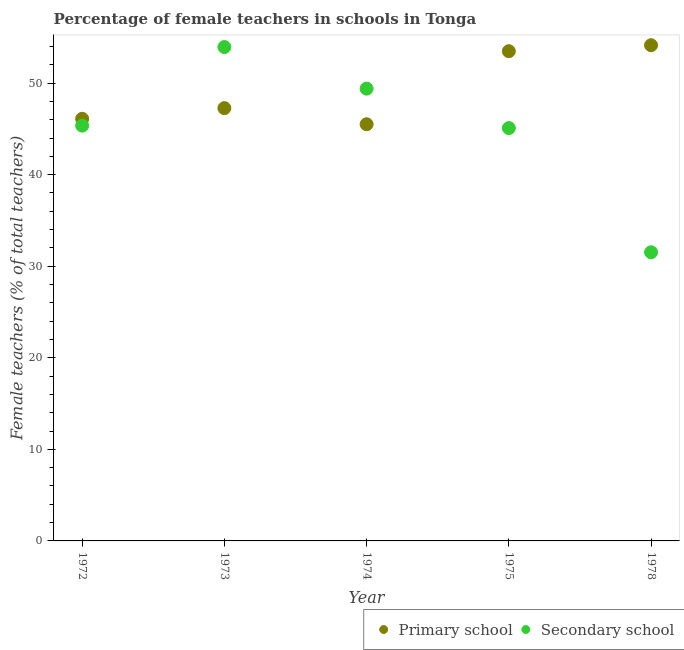How many different coloured dotlines are there?
Ensure brevity in your answer.  2. What is the percentage of female teachers in secondary schools in 1978?
Give a very brief answer. 31.53. Across all years, what is the maximum percentage of female teachers in secondary schools?
Provide a short and direct response. 53.94. Across all years, what is the minimum percentage of female teachers in secondary schools?
Give a very brief answer. 31.53. In which year was the percentage of female teachers in primary schools maximum?
Offer a very short reply. 1978. In which year was the percentage of female teachers in primary schools minimum?
Ensure brevity in your answer.  1974. What is the total percentage of female teachers in primary schools in the graph?
Keep it short and to the point. 246.51. What is the difference between the percentage of female teachers in primary schools in 1972 and that in 1973?
Offer a terse response. -1.16. What is the difference between the percentage of female teachers in primary schools in 1972 and the percentage of female teachers in secondary schools in 1978?
Ensure brevity in your answer.  14.58. What is the average percentage of female teachers in secondary schools per year?
Offer a terse response. 45.06. In the year 1975, what is the difference between the percentage of female teachers in secondary schools and percentage of female teachers in primary schools?
Your answer should be very brief. -8.4. What is the ratio of the percentage of female teachers in primary schools in 1973 to that in 1975?
Your answer should be very brief. 0.88. What is the difference between the highest and the second highest percentage of female teachers in primary schools?
Offer a very short reply. 0.65. What is the difference between the highest and the lowest percentage of female teachers in secondary schools?
Provide a succinct answer. 22.42. Is the sum of the percentage of female teachers in primary schools in 1972 and 1974 greater than the maximum percentage of female teachers in secondary schools across all years?
Provide a succinct answer. Yes. Is the percentage of female teachers in primary schools strictly less than the percentage of female teachers in secondary schools over the years?
Provide a succinct answer. No. What is the difference between two consecutive major ticks on the Y-axis?
Give a very brief answer. 10. Are the values on the major ticks of Y-axis written in scientific E-notation?
Make the answer very short. No. Where does the legend appear in the graph?
Offer a very short reply. Bottom right. How many legend labels are there?
Provide a succinct answer. 2. How are the legend labels stacked?
Give a very brief answer. Horizontal. What is the title of the graph?
Provide a succinct answer. Percentage of female teachers in schools in Tonga. What is the label or title of the Y-axis?
Keep it short and to the point. Female teachers (% of total teachers). What is the Female teachers (% of total teachers) in Primary school in 1972?
Keep it short and to the point. 46.11. What is the Female teachers (% of total teachers) of Secondary school in 1972?
Provide a succinct answer. 45.36. What is the Female teachers (% of total teachers) in Primary school in 1973?
Your response must be concise. 47.27. What is the Female teachers (% of total teachers) in Secondary school in 1973?
Ensure brevity in your answer.  53.94. What is the Female teachers (% of total teachers) of Primary school in 1974?
Ensure brevity in your answer.  45.51. What is the Female teachers (% of total teachers) in Secondary school in 1974?
Your answer should be compact. 49.4. What is the Female teachers (% of total teachers) of Primary school in 1975?
Provide a succinct answer. 53.49. What is the Female teachers (% of total teachers) in Secondary school in 1975?
Offer a very short reply. 45.09. What is the Female teachers (% of total teachers) in Primary school in 1978?
Your answer should be compact. 54.14. What is the Female teachers (% of total teachers) of Secondary school in 1978?
Give a very brief answer. 31.53. Across all years, what is the maximum Female teachers (% of total teachers) in Primary school?
Provide a succinct answer. 54.14. Across all years, what is the maximum Female teachers (% of total teachers) in Secondary school?
Offer a very short reply. 53.94. Across all years, what is the minimum Female teachers (% of total teachers) in Primary school?
Give a very brief answer. 45.51. Across all years, what is the minimum Female teachers (% of total teachers) of Secondary school?
Provide a short and direct response. 31.53. What is the total Female teachers (% of total teachers) of Primary school in the graph?
Your response must be concise. 246.51. What is the total Female teachers (% of total teachers) in Secondary school in the graph?
Offer a very short reply. 225.32. What is the difference between the Female teachers (% of total teachers) in Primary school in 1972 and that in 1973?
Your answer should be compact. -1.16. What is the difference between the Female teachers (% of total teachers) of Secondary school in 1972 and that in 1973?
Provide a short and direct response. -8.59. What is the difference between the Female teachers (% of total teachers) of Primary school in 1972 and that in 1974?
Offer a very short reply. 0.6. What is the difference between the Female teachers (% of total teachers) in Secondary school in 1972 and that in 1974?
Provide a short and direct response. -4.04. What is the difference between the Female teachers (% of total teachers) of Primary school in 1972 and that in 1975?
Your answer should be very brief. -7.38. What is the difference between the Female teachers (% of total teachers) of Secondary school in 1972 and that in 1975?
Offer a terse response. 0.27. What is the difference between the Female teachers (% of total teachers) in Primary school in 1972 and that in 1978?
Your answer should be very brief. -8.03. What is the difference between the Female teachers (% of total teachers) of Secondary school in 1972 and that in 1978?
Your answer should be compact. 13.83. What is the difference between the Female teachers (% of total teachers) in Primary school in 1973 and that in 1974?
Your answer should be very brief. 1.76. What is the difference between the Female teachers (% of total teachers) in Secondary school in 1973 and that in 1974?
Ensure brevity in your answer.  4.54. What is the difference between the Female teachers (% of total teachers) of Primary school in 1973 and that in 1975?
Offer a terse response. -6.22. What is the difference between the Female teachers (% of total teachers) in Secondary school in 1973 and that in 1975?
Provide a succinct answer. 8.85. What is the difference between the Female teachers (% of total teachers) of Primary school in 1973 and that in 1978?
Your answer should be compact. -6.87. What is the difference between the Female teachers (% of total teachers) in Secondary school in 1973 and that in 1978?
Your answer should be very brief. 22.42. What is the difference between the Female teachers (% of total teachers) of Primary school in 1974 and that in 1975?
Your answer should be very brief. -7.98. What is the difference between the Female teachers (% of total teachers) in Secondary school in 1974 and that in 1975?
Your response must be concise. 4.31. What is the difference between the Female teachers (% of total teachers) in Primary school in 1974 and that in 1978?
Provide a succinct answer. -8.63. What is the difference between the Female teachers (% of total teachers) in Secondary school in 1974 and that in 1978?
Provide a succinct answer. 17.87. What is the difference between the Female teachers (% of total teachers) in Primary school in 1975 and that in 1978?
Provide a succinct answer. -0.65. What is the difference between the Female teachers (% of total teachers) in Secondary school in 1975 and that in 1978?
Your response must be concise. 13.56. What is the difference between the Female teachers (% of total teachers) in Primary school in 1972 and the Female teachers (% of total teachers) in Secondary school in 1973?
Offer a very short reply. -7.84. What is the difference between the Female teachers (% of total teachers) of Primary school in 1972 and the Female teachers (% of total teachers) of Secondary school in 1974?
Offer a very short reply. -3.29. What is the difference between the Female teachers (% of total teachers) of Primary school in 1972 and the Female teachers (% of total teachers) of Secondary school in 1975?
Provide a succinct answer. 1.01. What is the difference between the Female teachers (% of total teachers) of Primary school in 1972 and the Female teachers (% of total teachers) of Secondary school in 1978?
Your response must be concise. 14.58. What is the difference between the Female teachers (% of total teachers) of Primary school in 1973 and the Female teachers (% of total teachers) of Secondary school in 1974?
Offer a very short reply. -2.13. What is the difference between the Female teachers (% of total teachers) in Primary school in 1973 and the Female teachers (% of total teachers) in Secondary school in 1975?
Give a very brief answer. 2.18. What is the difference between the Female teachers (% of total teachers) of Primary school in 1973 and the Female teachers (% of total teachers) of Secondary school in 1978?
Your response must be concise. 15.74. What is the difference between the Female teachers (% of total teachers) in Primary school in 1974 and the Female teachers (% of total teachers) in Secondary school in 1975?
Make the answer very short. 0.42. What is the difference between the Female teachers (% of total teachers) of Primary school in 1974 and the Female teachers (% of total teachers) of Secondary school in 1978?
Give a very brief answer. 13.98. What is the difference between the Female teachers (% of total teachers) of Primary school in 1975 and the Female teachers (% of total teachers) of Secondary school in 1978?
Offer a very short reply. 21.96. What is the average Female teachers (% of total teachers) of Primary school per year?
Your answer should be very brief. 49.3. What is the average Female teachers (% of total teachers) in Secondary school per year?
Offer a terse response. 45.06. In the year 1972, what is the difference between the Female teachers (% of total teachers) of Primary school and Female teachers (% of total teachers) of Secondary school?
Your answer should be very brief. 0.75. In the year 1973, what is the difference between the Female teachers (% of total teachers) of Primary school and Female teachers (% of total teachers) of Secondary school?
Keep it short and to the point. -6.67. In the year 1974, what is the difference between the Female teachers (% of total teachers) in Primary school and Female teachers (% of total teachers) in Secondary school?
Your answer should be compact. -3.89. In the year 1975, what is the difference between the Female teachers (% of total teachers) in Primary school and Female teachers (% of total teachers) in Secondary school?
Your answer should be compact. 8.4. In the year 1978, what is the difference between the Female teachers (% of total teachers) in Primary school and Female teachers (% of total teachers) in Secondary school?
Offer a terse response. 22.61. What is the ratio of the Female teachers (% of total teachers) in Primary school in 1972 to that in 1973?
Your answer should be very brief. 0.98. What is the ratio of the Female teachers (% of total teachers) in Secondary school in 1972 to that in 1973?
Your response must be concise. 0.84. What is the ratio of the Female teachers (% of total teachers) in Primary school in 1972 to that in 1974?
Offer a very short reply. 1.01. What is the ratio of the Female teachers (% of total teachers) in Secondary school in 1972 to that in 1974?
Provide a succinct answer. 0.92. What is the ratio of the Female teachers (% of total teachers) in Primary school in 1972 to that in 1975?
Make the answer very short. 0.86. What is the ratio of the Female teachers (% of total teachers) in Secondary school in 1972 to that in 1975?
Ensure brevity in your answer.  1.01. What is the ratio of the Female teachers (% of total teachers) in Primary school in 1972 to that in 1978?
Offer a very short reply. 0.85. What is the ratio of the Female teachers (% of total teachers) of Secondary school in 1972 to that in 1978?
Your answer should be very brief. 1.44. What is the ratio of the Female teachers (% of total teachers) of Primary school in 1973 to that in 1974?
Give a very brief answer. 1.04. What is the ratio of the Female teachers (% of total teachers) in Secondary school in 1973 to that in 1974?
Provide a succinct answer. 1.09. What is the ratio of the Female teachers (% of total teachers) in Primary school in 1973 to that in 1975?
Your response must be concise. 0.88. What is the ratio of the Female teachers (% of total teachers) in Secondary school in 1973 to that in 1975?
Your answer should be compact. 1.2. What is the ratio of the Female teachers (% of total teachers) in Primary school in 1973 to that in 1978?
Provide a short and direct response. 0.87. What is the ratio of the Female teachers (% of total teachers) in Secondary school in 1973 to that in 1978?
Provide a short and direct response. 1.71. What is the ratio of the Female teachers (% of total teachers) of Primary school in 1974 to that in 1975?
Make the answer very short. 0.85. What is the ratio of the Female teachers (% of total teachers) in Secondary school in 1974 to that in 1975?
Ensure brevity in your answer.  1.1. What is the ratio of the Female teachers (% of total teachers) in Primary school in 1974 to that in 1978?
Offer a terse response. 0.84. What is the ratio of the Female teachers (% of total teachers) in Secondary school in 1974 to that in 1978?
Your answer should be very brief. 1.57. What is the ratio of the Female teachers (% of total teachers) of Secondary school in 1975 to that in 1978?
Your answer should be very brief. 1.43. What is the difference between the highest and the second highest Female teachers (% of total teachers) in Primary school?
Offer a terse response. 0.65. What is the difference between the highest and the second highest Female teachers (% of total teachers) of Secondary school?
Your response must be concise. 4.54. What is the difference between the highest and the lowest Female teachers (% of total teachers) in Primary school?
Your response must be concise. 8.63. What is the difference between the highest and the lowest Female teachers (% of total teachers) in Secondary school?
Keep it short and to the point. 22.42. 